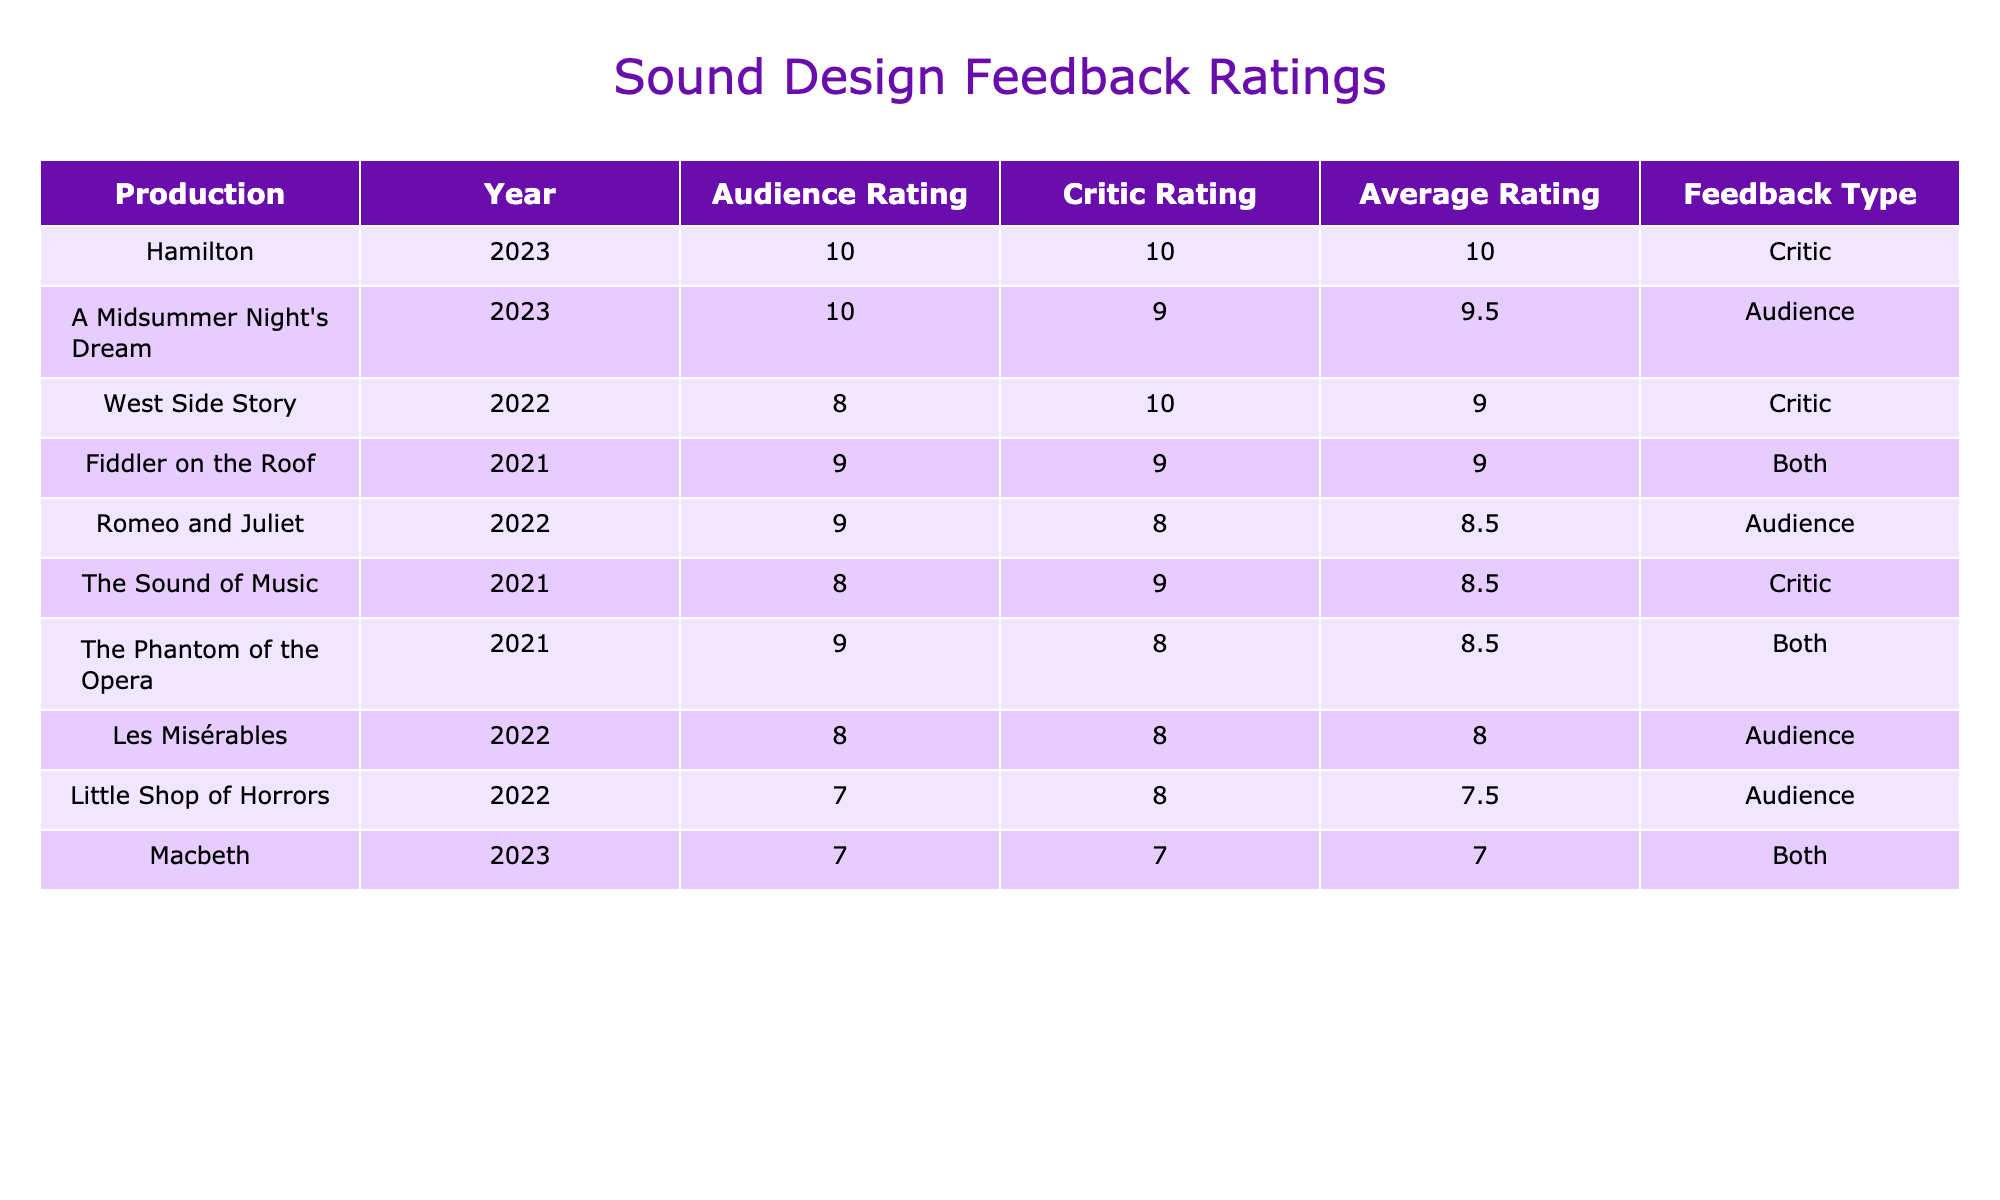What is the highest audience rating in the table? The highest audience rating is found in the row for "A Midsummer Night's Dream" (2023) which has a rating of 10.
Answer: 10 Which production received both audience and critic feedback? "Macbeth" (2023) and "The Phantom of the Opera" (2021) are the productions that received ratings from both audiences and critics, evident from the "Both" in the Feedback Type column.
Answer: "Macbeth" and "The Phantom of the Opera" What is the average rating of "Les Misérables"? To calculate the average rating for "Les Misérables" (2022), we take the audience rating of 8 and the critic rating of 8, then average them: (8 + 8) / 2 = 8.
Answer: 8 Is there any production that received a critic rating of 10? Yes, "Hamilton" (2023) received a critic rating of 10 as per the Critic Rating column.
Answer: Yes Which production has the lowest average rating and what is it? To find the lowest average rating, we calculate the averages for all productions: "Macbeth" (7), "Little Shop of Horrors" (7), and so on. The lowest average is for "Macbeth" with an average of 7.
Answer: "Macbeth", 7 How many productions have a higher audience rating than their critic rating? Observing the table, productions like "Romeo and Juliet", "A Midsummer Night's Dream", "The Phantom of the Opera", "Les Misérables", and "Little Shop of Horrors" have higher audience ratings than their critic ratings, totaling 5 such productions.
Answer: 5 What is the difference in ratings between "Fiddler on the Roof" and "West Side Story"? "Fiddler on the Roof" has an audience rating of 9 and a critic rating of 9, giving it an average of 9. "West Side Story" has an audience rating of 8 and a critic rating of 10, averaging 9. The difference in average ratings is 9 - 9 = 0.
Answer: 0 Which production had the highest critic rating and what was the average rating? "Hamilton" (2023) had the highest critic rating of 10. Its average rating is also 10 since both audience and critic ratings are 10.
Answer: "Hamilton", 10 What is the count of productions that received ratings only from the audience? The productions that received ratings only from the audience are: "Romeo and Juliet", "A Midsummer Night's Dream", and "Little Shop of Horrors", which totals to 3.
Answer: 3 